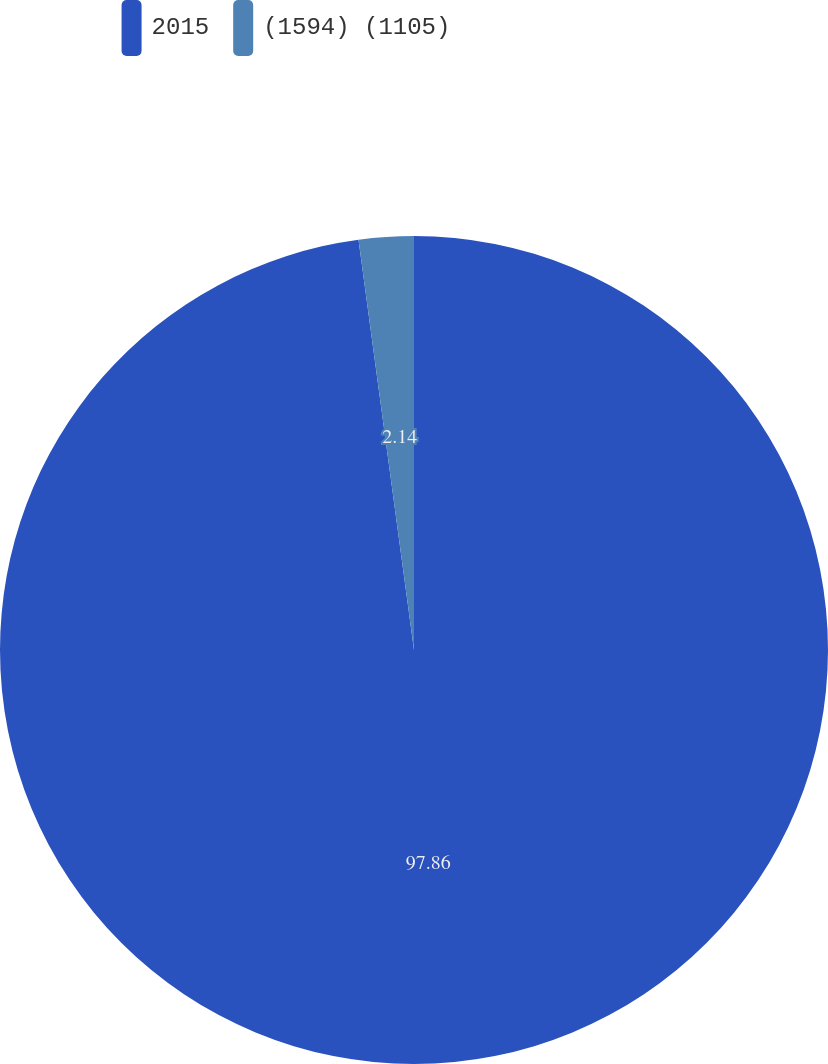<chart> <loc_0><loc_0><loc_500><loc_500><pie_chart><fcel>2015<fcel>(1594) (1105)<nl><fcel>97.86%<fcel>2.14%<nl></chart> 